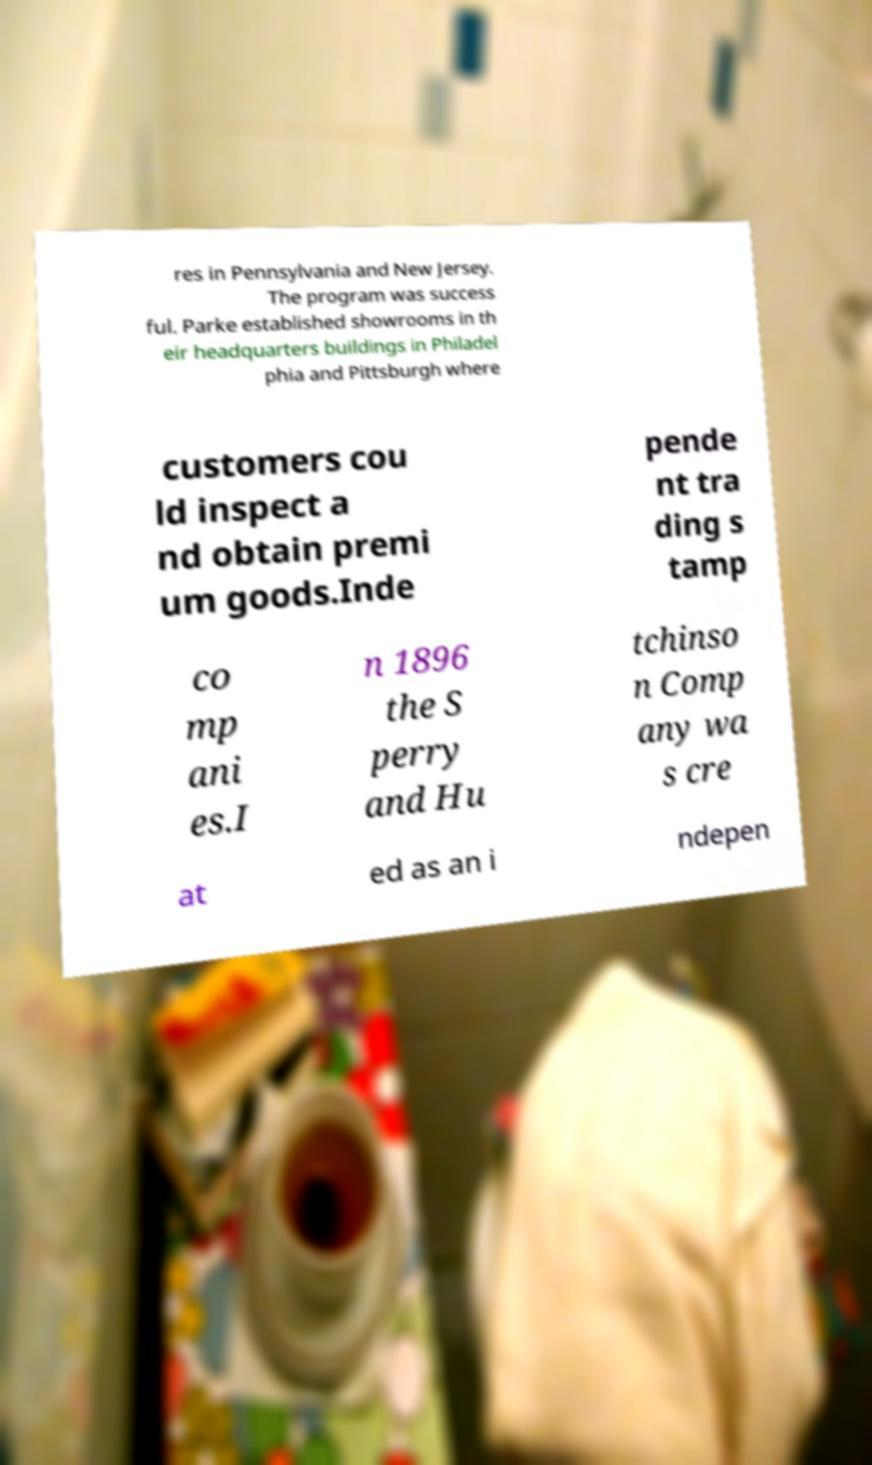Could you assist in decoding the text presented in this image and type it out clearly? res in Pennsylvania and New Jersey. The program was success ful. Parke established showrooms in th eir headquarters buildings in Philadel phia and Pittsburgh where customers cou ld inspect a nd obtain premi um goods.Inde pende nt tra ding s tamp co mp ani es.I n 1896 the S perry and Hu tchinso n Comp any wa s cre at ed as an i ndepen 